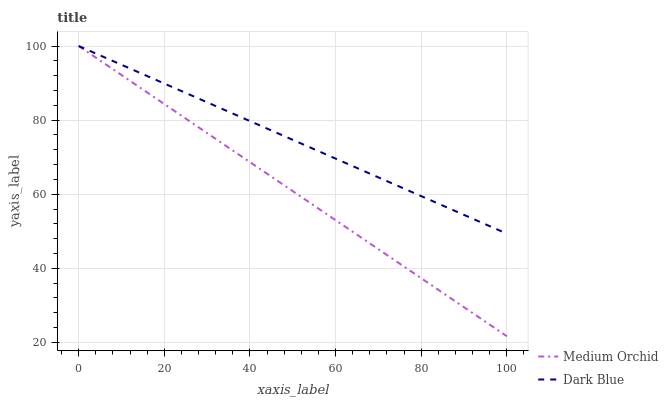Does Medium Orchid have the minimum area under the curve?
Answer yes or no. Yes. Does Dark Blue have the maximum area under the curve?
Answer yes or no. Yes. Does Medium Orchid have the maximum area under the curve?
Answer yes or no. No. Is Medium Orchid the smoothest?
Answer yes or no. Yes. Is Dark Blue the roughest?
Answer yes or no. Yes. Is Medium Orchid the roughest?
Answer yes or no. No. Does Medium Orchid have the lowest value?
Answer yes or no. Yes. Does Medium Orchid have the highest value?
Answer yes or no. Yes. Does Dark Blue intersect Medium Orchid?
Answer yes or no. Yes. Is Dark Blue less than Medium Orchid?
Answer yes or no. No. Is Dark Blue greater than Medium Orchid?
Answer yes or no. No. 